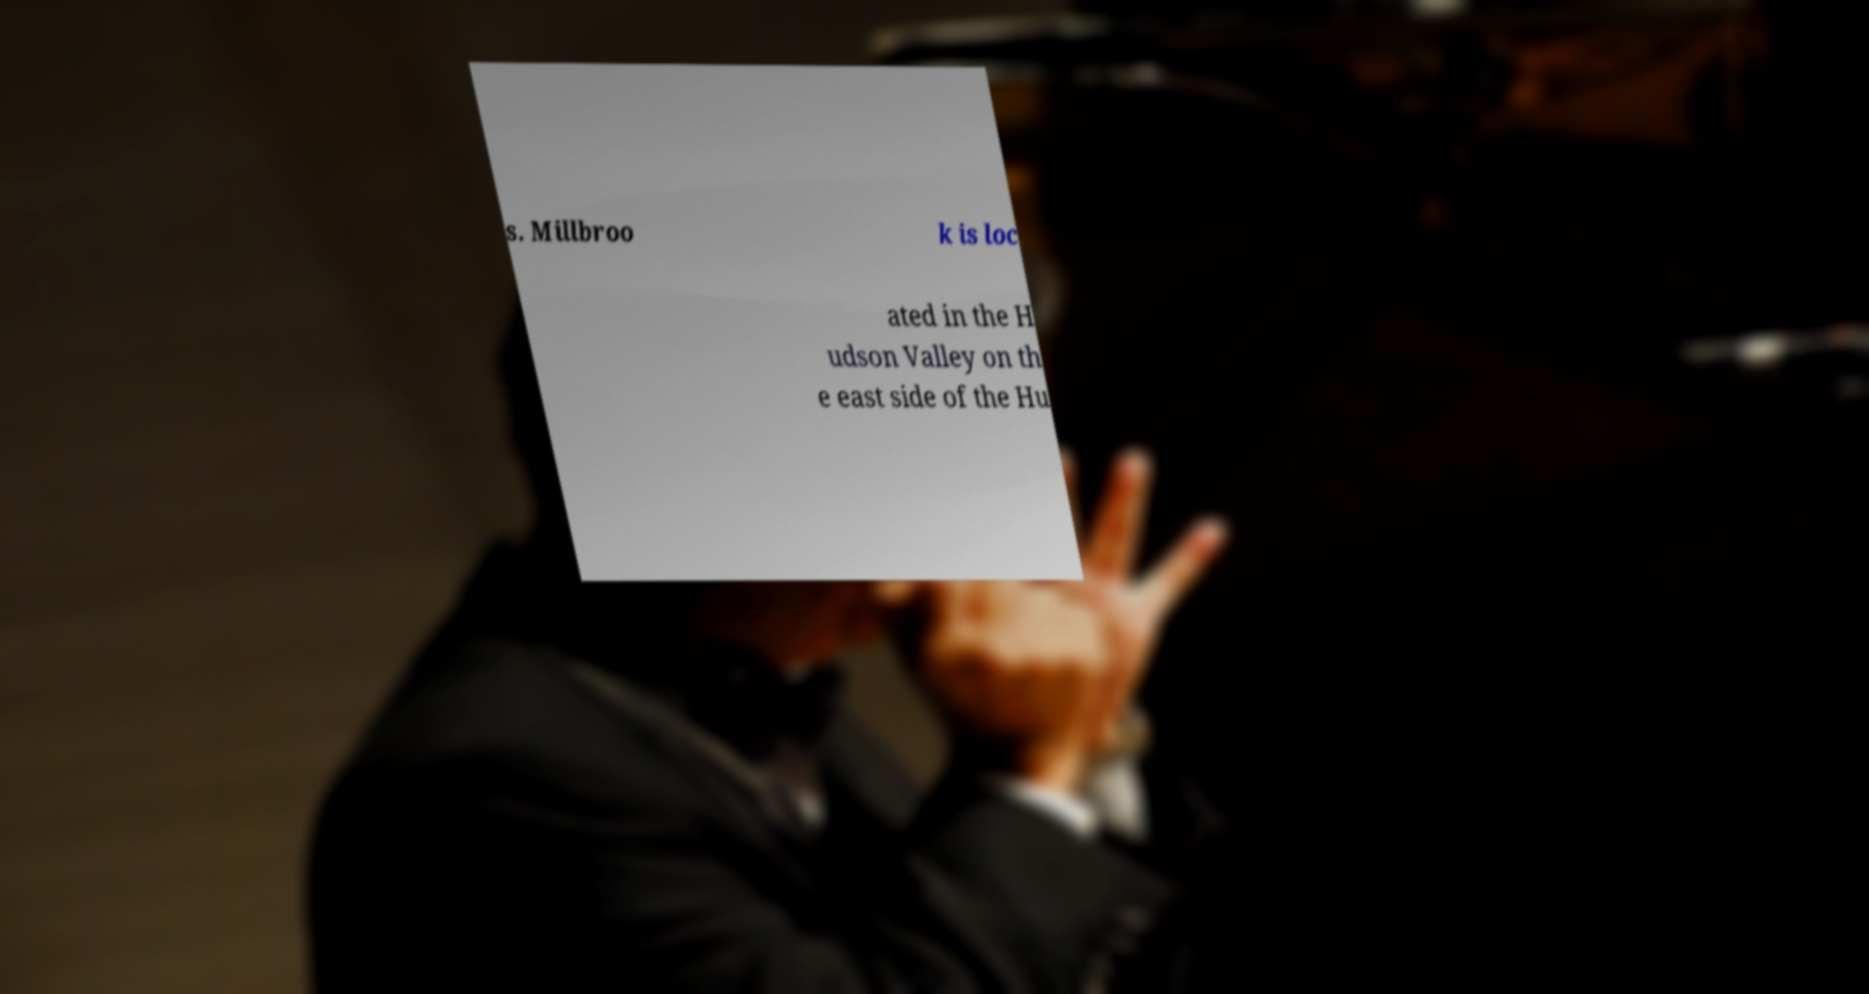Could you assist in decoding the text presented in this image and type it out clearly? s. Millbroo k is loc ated in the H udson Valley on th e east side of the Hu 